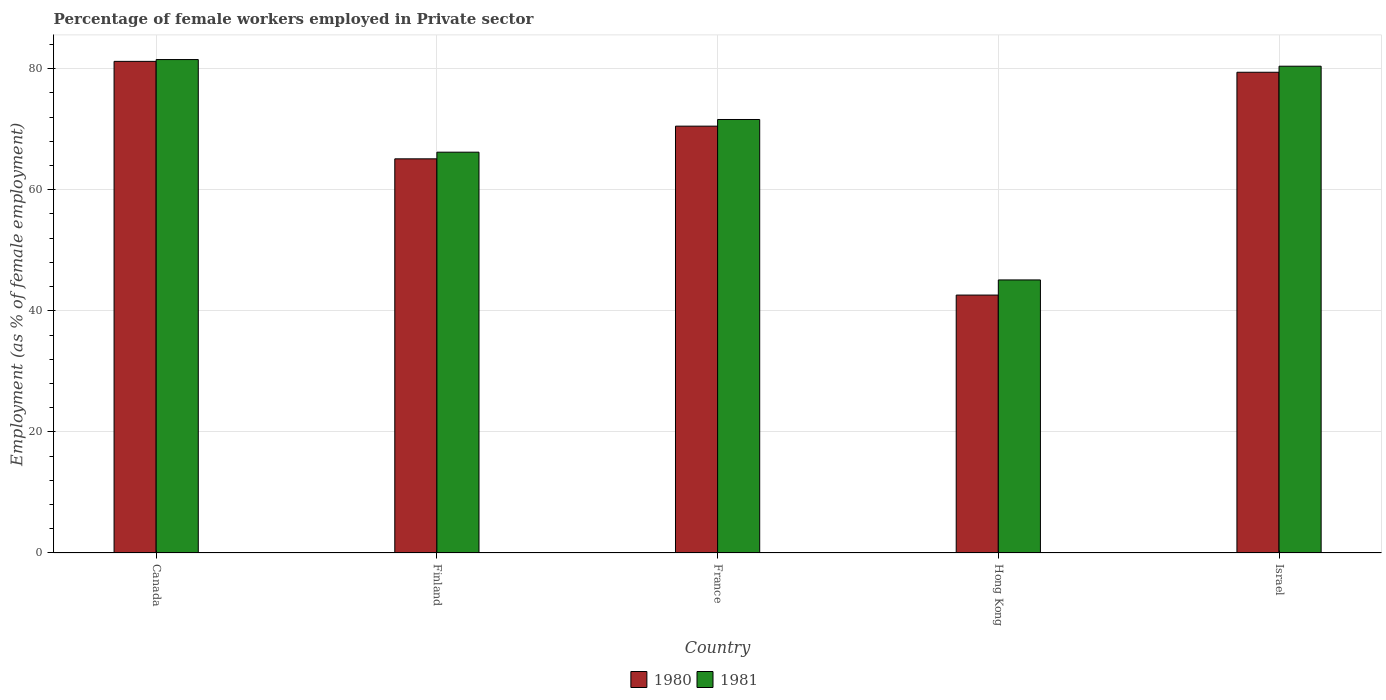How many groups of bars are there?
Your answer should be compact. 5. Are the number of bars per tick equal to the number of legend labels?
Make the answer very short. Yes. How many bars are there on the 1st tick from the left?
Offer a terse response. 2. How many bars are there on the 3rd tick from the right?
Ensure brevity in your answer.  2. What is the label of the 2nd group of bars from the left?
Give a very brief answer. Finland. What is the percentage of females employed in Private sector in 1981 in Hong Kong?
Your answer should be compact. 45.1. Across all countries, what is the maximum percentage of females employed in Private sector in 1980?
Keep it short and to the point. 81.2. Across all countries, what is the minimum percentage of females employed in Private sector in 1981?
Ensure brevity in your answer.  45.1. In which country was the percentage of females employed in Private sector in 1981 maximum?
Ensure brevity in your answer.  Canada. In which country was the percentage of females employed in Private sector in 1980 minimum?
Keep it short and to the point. Hong Kong. What is the total percentage of females employed in Private sector in 1981 in the graph?
Your answer should be compact. 344.8. What is the difference between the percentage of females employed in Private sector in 1980 in Finland and that in France?
Offer a terse response. -5.4. What is the difference between the percentage of females employed in Private sector in 1981 in Canada and the percentage of females employed in Private sector in 1980 in Israel?
Keep it short and to the point. 2.1. What is the average percentage of females employed in Private sector in 1980 per country?
Keep it short and to the point. 67.76. In how many countries, is the percentage of females employed in Private sector in 1980 greater than 68 %?
Offer a terse response. 3. What is the ratio of the percentage of females employed in Private sector in 1981 in Finland to that in Hong Kong?
Provide a succinct answer. 1.47. Is the percentage of females employed in Private sector in 1980 in Finland less than that in Hong Kong?
Keep it short and to the point. No. What is the difference between the highest and the second highest percentage of females employed in Private sector in 1980?
Provide a succinct answer. 10.7. What is the difference between the highest and the lowest percentage of females employed in Private sector in 1981?
Provide a short and direct response. 36.4. In how many countries, is the percentage of females employed in Private sector in 1981 greater than the average percentage of females employed in Private sector in 1981 taken over all countries?
Offer a terse response. 3. What does the 1st bar from the left in Hong Kong represents?
Provide a succinct answer. 1980. What does the 1st bar from the right in Finland represents?
Keep it short and to the point. 1981. How many bars are there?
Your answer should be compact. 10. Are all the bars in the graph horizontal?
Your response must be concise. No. Are the values on the major ticks of Y-axis written in scientific E-notation?
Provide a succinct answer. No. Does the graph contain any zero values?
Provide a short and direct response. No. Where does the legend appear in the graph?
Offer a terse response. Bottom center. How are the legend labels stacked?
Offer a terse response. Horizontal. What is the title of the graph?
Make the answer very short. Percentage of female workers employed in Private sector. Does "1995" appear as one of the legend labels in the graph?
Provide a succinct answer. No. What is the label or title of the X-axis?
Offer a very short reply. Country. What is the label or title of the Y-axis?
Provide a short and direct response. Employment (as % of female employment). What is the Employment (as % of female employment) of 1980 in Canada?
Provide a succinct answer. 81.2. What is the Employment (as % of female employment) in 1981 in Canada?
Provide a succinct answer. 81.5. What is the Employment (as % of female employment) of 1980 in Finland?
Offer a terse response. 65.1. What is the Employment (as % of female employment) of 1981 in Finland?
Your answer should be compact. 66.2. What is the Employment (as % of female employment) of 1980 in France?
Your answer should be very brief. 70.5. What is the Employment (as % of female employment) of 1981 in France?
Keep it short and to the point. 71.6. What is the Employment (as % of female employment) in 1980 in Hong Kong?
Your response must be concise. 42.6. What is the Employment (as % of female employment) of 1981 in Hong Kong?
Your answer should be compact. 45.1. What is the Employment (as % of female employment) of 1980 in Israel?
Give a very brief answer. 79.4. What is the Employment (as % of female employment) of 1981 in Israel?
Provide a succinct answer. 80.4. Across all countries, what is the maximum Employment (as % of female employment) in 1980?
Offer a very short reply. 81.2. Across all countries, what is the maximum Employment (as % of female employment) of 1981?
Offer a terse response. 81.5. Across all countries, what is the minimum Employment (as % of female employment) in 1980?
Provide a succinct answer. 42.6. Across all countries, what is the minimum Employment (as % of female employment) in 1981?
Your answer should be compact. 45.1. What is the total Employment (as % of female employment) in 1980 in the graph?
Give a very brief answer. 338.8. What is the total Employment (as % of female employment) of 1981 in the graph?
Offer a terse response. 344.8. What is the difference between the Employment (as % of female employment) in 1980 in Canada and that in France?
Your answer should be very brief. 10.7. What is the difference between the Employment (as % of female employment) in 1981 in Canada and that in France?
Make the answer very short. 9.9. What is the difference between the Employment (as % of female employment) of 1980 in Canada and that in Hong Kong?
Your answer should be compact. 38.6. What is the difference between the Employment (as % of female employment) in 1981 in Canada and that in Hong Kong?
Give a very brief answer. 36.4. What is the difference between the Employment (as % of female employment) of 1980 in Finland and that in France?
Give a very brief answer. -5.4. What is the difference between the Employment (as % of female employment) in 1980 in Finland and that in Hong Kong?
Keep it short and to the point. 22.5. What is the difference between the Employment (as % of female employment) of 1981 in Finland and that in Hong Kong?
Your answer should be compact. 21.1. What is the difference between the Employment (as % of female employment) of 1980 in Finland and that in Israel?
Provide a succinct answer. -14.3. What is the difference between the Employment (as % of female employment) of 1980 in France and that in Hong Kong?
Your response must be concise. 27.9. What is the difference between the Employment (as % of female employment) in 1981 in France and that in Hong Kong?
Offer a very short reply. 26.5. What is the difference between the Employment (as % of female employment) of 1980 in France and that in Israel?
Make the answer very short. -8.9. What is the difference between the Employment (as % of female employment) of 1981 in France and that in Israel?
Offer a terse response. -8.8. What is the difference between the Employment (as % of female employment) in 1980 in Hong Kong and that in Israel?
Your answer should be compact. -36.8. What is the difference between the Employment (as % of female employment) in 1981 in Hong Kong and that in Israel?
Your answer should be compact. -35.3. What is the difference between the Employment (as % of female employment) in 1980 in Canada and the Employment (as % of female employment) in 1981 in Finland?
Provide a succinct answer. 15. What is the difference between the Employment (as % of female employment) of 1980 in Canada and the Employment (as % of female employment) of 1981 in France?
Make the answer very short. 9.6. What is the difference between the Employment (as % of female employment) in 1980 in Canada and the Employment (as % of female employment) in 1981 in Hong Kong?
Offer a terse response. 36.1. What is the difference between the Employment (as % of female employment) of 1980 in Canada and the Employment (as % of female employment) of 1981 in Israel?
Offer a very short reply. 0.8. What is the difference between the Employment (as % of female employment) of 1980 in Finland and the Employment (as % of female employment) of 1981 in Hong Kong?
Keep it short and to the point. 20. What is the difference between the Employment (as % of female employment) in 1980 in Finland and the Employment (as % of female employment) in 1981 in Israel?
Offer a terse response. -15.3. What is the difference between the Employment (as % of female employment) of 1980 in France and the Employment (as % of female employment) of 1981 in Hong Kong?
Ensure brevity in your answer.  25.4. What is the difference between the Employment (as % of female employment) in 1980 in France and the Employment (as % of female employment) in 1981 in Israel?
Offer a terse response. -9.9. What is the difference between the Employment (as % of female employment) in 1980 in Hong Kong and the Employment (as % of female employment) in 1981 in Israel?
Provide a succinct answer. -37.8. What is the average Employment (as % of female employment) of 1980 per country?
Offer a very short reply. 67.76. What is the average Employment (as % of female employment) of 1981 per country?
Give a very brief answer. 68.96. What is the difference between the Employment (as % of female employment) in 1980 and Employment (as % of female employment) in 1981 in Finland?
Offer a terse response. -1.1. What is the difference between the Employment (as % of female employment) of 1980 and Employment (as % of female employment) of 1981 in France?
Provide a succinct answer. -1.1. What is the difference between the Employment (as % of female employment) in 1980 and Employment (as % of female employment) in 1981 in Israel?
Provide a succinct answer. -1. What is the ratio of the Employment (as % of female employment) of 1980 in Canada to that in Finland?
Your response must be concise. 1.25. What is the ratio of the Employment (as % of female employment) of 1981 in Canada to that in Finland?
Ensure brevity in your answer.  1.23. What is the ratio of the Employment (as % of female employment) in 1980 in Canada to that in France?
Offer a very short reply. 1.15. What is the ratio of the Employment (as % of female employment) in 1981 in Canada to that in France?
Keep it short and to the point. 1.14. What is the ratio of the Employment (as % of female employment) in 1980 in Canada to that in Hong Kong?
Ensure brevity in your answer.  1.91. What is the ratio of the Employment (as % of female employment) of 1981 in Canada to that in Hong Kong?
Provide a short and direct response. 1.81. What is the ratio of the Employment (as % of female employment) in 1980 in Canada to that in Israel?
Your answer should be very brief. 1.02. What is the ratio of the Employment (as % of female employment) of 1981 in Canada to that in Israel?
Your response must be concise. 1.01. What is the ratio of the Employment (as % of female employment) in 1980 in Finland to that in France?
Make the answer very short. 0.92. What is the ratio of the Employment (as % of female employment) in 1981 in Finland to that in France?
Your response must be concise. 0.92. What is the ratio of the Employment (as % of female employment) of 1980 in Finland to that in Hong Kong?
Offer a very short reply. 1.53. What is the ratio of the Employment (as % of female employment) of 1981 in Finland to that in Hong Kong?
Keep it short and to the point. 1.47. What is the ratio of the Employment (as % of female employment) in 1980 in Finland to that in Israel?
Your answer should be very brief. 0.82. What is the ratio of the Employment (as % of female employment) of 1981 in Finland to that in Israel?
Ensure brevity in your answer.  0.82. What is the ratio of the Employment (as % of female employment) of 1980 in France to that in Hong Kong?
Offer a terse response. 1.65. What is the ratio of the Employment (as % of female employment) of 1981 in France to that in Hong Kong?
Your answer should be very brief. 1.59. What is the ratio of the Employment (as % of female employment) of 1980 in France to that in Israel?
Your response must be concise. 0.89. What is the ratio of the Employment (as % of female employment) of 1981 in France to that in Israel?
Your response must be concise. 0.89. What is the ratio of the Employment (as % of female employment) of 1980 in Hong Kong to that in Israel?
Provide a short and direct response. 0.54. What is the ratio of the Employment (as % of female employment) of 1981 in Hong Kong to that in Israel?
Your answer should be very brief. 0.56. What is the difference between the highest and the second highest Employment (as % of female employment) in 1980?
Your answer should be very brief. 1.8. What is the difference between the highest and the second highest Employment (as % of female employment) of 1981?
Keep it short and to the point. 1.1. What is the difference between the highest and the lowest Employment (as % of female employment) of 1980?
Ensure brevity in your answer.  38.6. What is the difference between the highest and the lowest Employment (as % of female employment) of 1981?
Offer a very short reply. 36.4. 